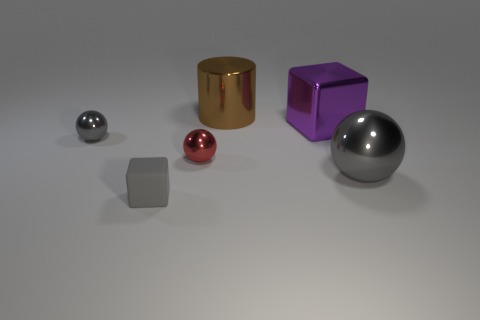Can you describe the different materials of the objects? Certainly! In the image, there are objects with different surface appearances which suggest a variety of materials. From left to right: The first sphere looks like it's made of a smooth, polished metal. The small cube seems to be a matte lighter metal, possibly painted or treated steel. The next sphere appears reflective like polished copper or perhaps a coated material. The cylinder and the cube have a glossy finish, likely a metallic paint, with the cylinder resembling gold and the cube resembling a purple metallic sheen. Lastly, the sphere on the far right looks to be a highly reflective metal, similar to chromium.  How does the lighting affect the appearance of the materials? The lighting plays a vital role in conveying the material characteristics of the objects. The soft and diffused light helps create subtle shadows and gentle reflections, emphasizing the smoothness and sheen of the metallic surfaces. The matte cube absorbs more light, showing less reflection, which makes it stand out as less shiny compared to the other objects. The gold cylinder and purple cube reflect more light, showcasing their glossy nature, and the bright specular highlights on the reflective spheres indicate a very smooth and possibly polished metal finish. 